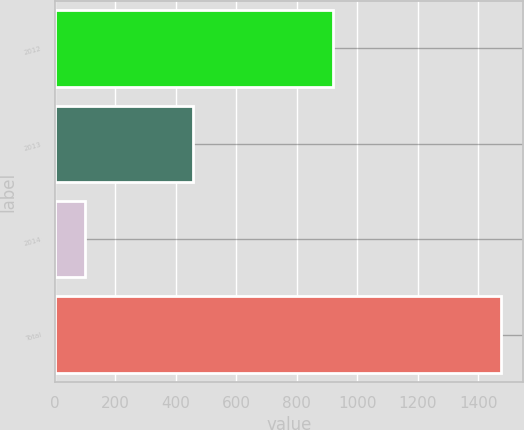Convert chart. <chart><loc_0><loc_0><loc_500><loc_500><bar_chart><fcel>2012<fcel>2013<fcel>2014<fcel>Total<nl><fcel>919<fcel>456<fcel>100<fcel>1475<nl></chart> 